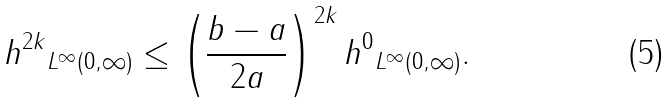<formula> <loc_0><loc_0><loc_500><loc_500>\| h ^ { 2 k } \| _ { L ^ { \infty } ( 0 , \infty ) } \leq \left ( \frac { b - a } { 2 a } \right ) ^ { 2 k } \| h ^ { 0 } \| _ { L ^ { \infty } ( 0 , \infty ) } .</formula> 